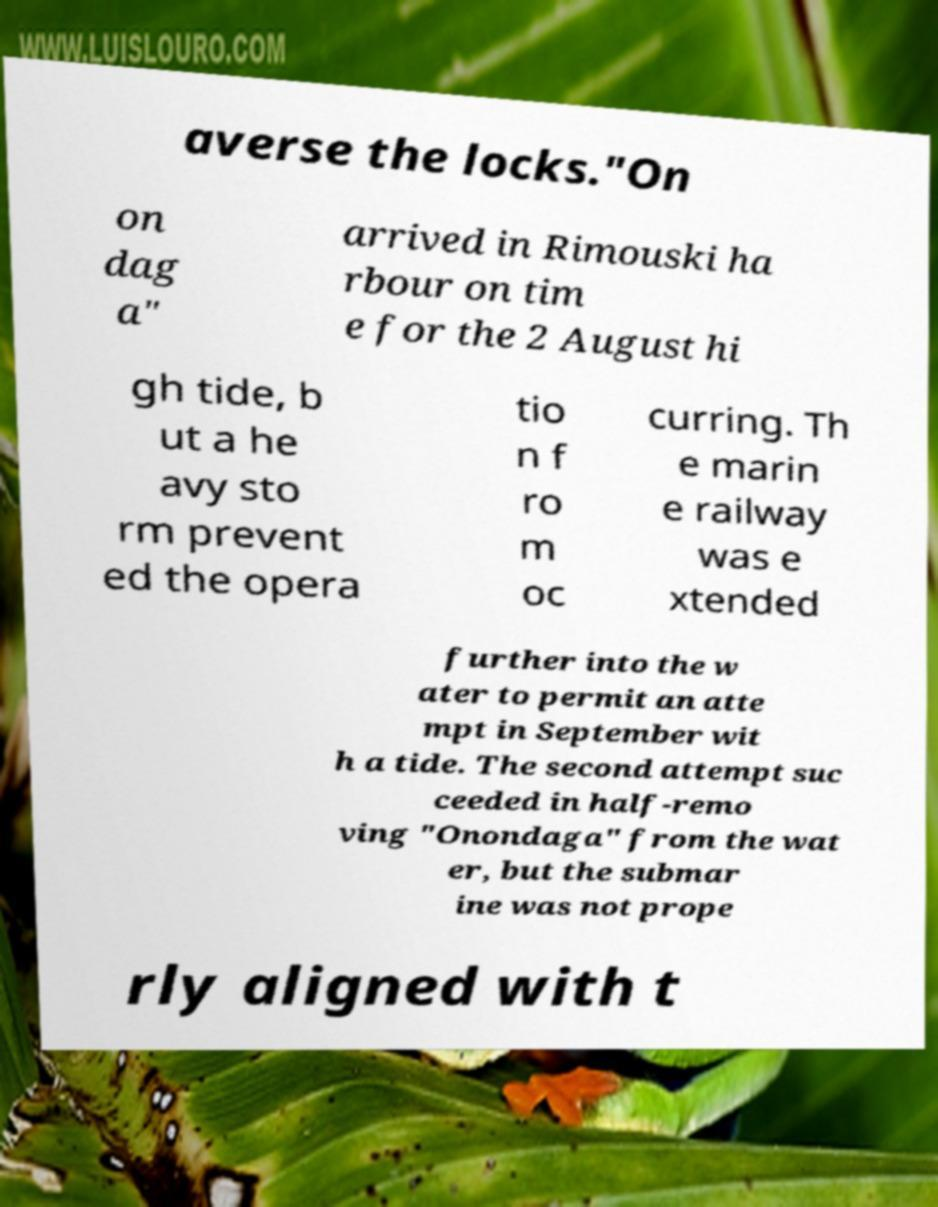Could you extract and type out the text from this image? averse the locks."On on dag a" arrived in Rimouski ha rbour on tim e for the 2 August hi gh tide, b ut a he avy sto rm prevent ed the opera tio n f ro m oc curring. Th e marin e railway was e xtended further into the w ater to permit an atte mpt in September wit h a tide. The second attempt suc ceeded in half-remo ving "Onondaga" from the wat er, but the submar ine was not prope rly aligned with t 